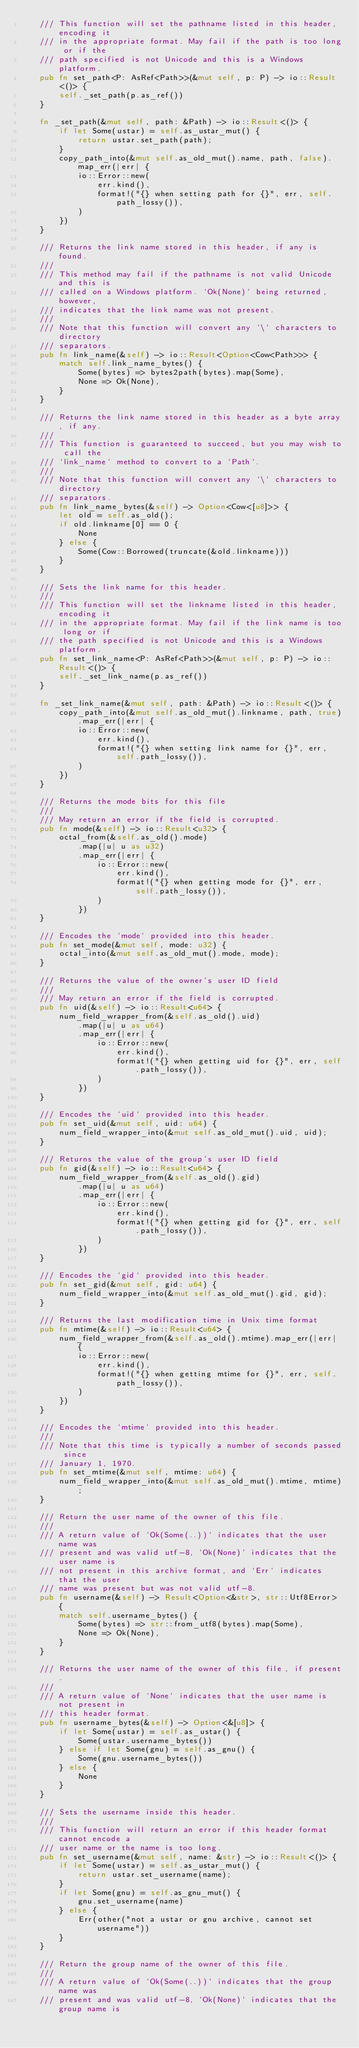<code> <loc_0><loc_0><loc_500><loc_500><_Rust_>    /// This function will set the pathname listed in this header, encoding it
    /// in the appropriate format. May fail if the path is too long or if the
    /// path specified is not Unicode and this is a Windows platform.
    pub fn set_path<P: AsRef<Path>>(&mut self, p: P) -> io::Result<()> {
        self._set_path(p.as_ref())
    }

    fn _set_path(&mut self, path: &Path) -> io::Result<()> {
        if let Some(ustar) = self.as_ustar_mut() {
            return ustar.set_path(path);
        }
        copy_path_into(&mut self.as_old_mut().name, path, false).map_err(|err| {
            io::Error::new(
                err.kind(),
                format!("{} when setting path for {}", err, self.path_lossy()),
            )
        })
    }

    /// Returns the link name stored in this header, if any is found.
    ///
    /// This method may fail if the pathname is not valid Unicode and this is
    /// called on a Windows platform. `Ok(None)` being returned, however,
    /// indicates that the link name was not present.
    ///
    /// Note that this function will convert any `\` characters to directory
    /// separators.
    pub fn link_name(&self) -> io::Result<Option<Cow<Path>>> {
        match self.link_name_bytes() {
            Some(bytes) => bytes2path(bytes).map(Some),
            None => Ok(None),
        }
    }

    /// Returns the link name stored in this header as a byte array, if any.
    ///
    /// This function is guaranteed to succeed, but you may wish to call the
    /// `link_name` method to convert to a `Path`.
    ///
    /// Note that this function will convert any `\` characters to directory
    /// separators.
    pub fn link_name_bytes(&self) -> Option<Cow<[u8]>> {
        let old = self.as_old();
        if old.linkname[0] == 0 {
            None
        } else {
            Some(Cow::Borrowed(truncate(&old.linkname)))
        }
    }

    /// Sets the link name for this header.
    ///
    /// This function will set the linkname listed in this header, encoding it
    /// in the appropriate format. May fail if the link name is too long or if
    /// the path specified is not Unicode and this is a Windows platform.
    pub fn set_link_name<P: AsRef<Path>>(&mut self, p: P) -> io::Result<()> {
        self._set_link_name(p.as_ref())
    }

    fn _set_link_name(&mut self, path: &Path) -> io::Result<()> {
        copy_path_into(&mut self.as_old_mut().linkname, path, true).map_err(|err| {
            io::Error::new(
                err.kind(),
                format!("{} when setting link name for {}", err, self.path_lossy()),
            )
        })
    }

    /// Returns the mode bits for this file
    ///
    /// May return an error if the field is corrupted.
    pub fn mode(&self) -> io::Result<u32> {
        octal_from(&self.as_old().mode)
            .map(|u| u as u32)
            .map_err(|err| {
                io::Error::new(
                    err.kind(),
                    format!("{} when getting mode for {}", err, self.path_lossy()),
                )
            })
    }

    /// Encodes the `mode` provided into this header.
    pub fn set_mode(&mut self, mode: u32) {
        octal_into(&mut self.as_old_mut().mode, mode);
    }

    /// Returns the value of the owner's user ID field
    ///
    /// May return an error if the field is corrupted.
    pub fn uid(&self) -> io::Result<u64> {
        num_field_wrapper_from(&self.as_old().uid)
            .map(|u| u as u64)
            .map_err(|err| {
                io::Error::new(
                    err.kind(),
                    format!("{} when getting uid for {}", err, self.path_lossy()),
                )
            })
    }

    /// Encodes the `uid` provided into this header.
    pub fn set_uid(&mut self, uid: u64) {
        num_field_wrapper_into(&mut self.as_old_mut().uid, uid);
    }

    /// Returns the value of the group's user ID field
    pub fn gid(&self) -> io::Result<u64> {
        num_field_wrapper_from(&self.as_old().gid)
            .map(|u| u as u64)
            .map_err(|err| {
                io::Error::new(
                    err.kind(),
                    format!("{} when getting gid for {}", err, self.path_lossy()),
                )
            })
    }

    /// Encodes the `gid` provided into this header.
    pub fn set_gid(&mut self, gid: u64) {
        num_field_wrapper_into(&mut self.as_old_mut().gid, gid);
    }

    /// Returns the last modification time in Unix time format
    pub fn mtime(&self) -> io::Result<u64> {
        num_field_wrapper_from(&self.as_old().mtime).map_err(|err| {
            io::Error::new(
                err.kind(),
                format!("{} when getting mtime for {}", err, self.path_lossy()),
            )
        })
    }

    /// Encodes the `mtime` provided into this header.
    ///
    /// Note that this time is typically a number of seconds passed since
    /// January 1, 1970.
    pub fn set_mtime(&mut self, mtime: u64) {
        num_field_wrapper_into(&mut self.as_old_mut().mtime, mtime);
    }

    /// Return the user name of the owner of this file.
    ///
    /// A return value of `Ok(Some(..))` indicates that the user name was
    /// present and was valid utf-8, `Ok(None)` indicates that the user name is
    /// not present in this archive format, and `Err` indicates that the user
    /// name was present but was not valid utf-8.
    pub fn username(&self) -> Result<Option<&str>, str::Utf8Error> {
        match self.username_bytes() {
            Some(bytes) => str::from_utf8(bytes).map(Some),
            None => Ok(None),
        }
    }

    /// Returns the user name of the owner of this file, if present.
    ///
    /// A return value of `None` indicates that the user name is not present in
    /// this header format.
    pub fn username_bytes(&self) -> Option<&[u8]> {
        if let Some(ustar) = self.as_ustar() {
            Some(ustar.username_bytes())
        } else if let Some(gnu) = self.as_gnu() {
            Some(gnu.username_bytes())
        } else {
            None
        }
    }

    /// Sets the username inside this header.
    ///
    /// This function will return an error if this header format cannot encode a
    /// user name or the name is too long.
    pub fn set_username(&mut self, name: &str) -> io::Result<()> {
        if let Some(ustar) = self.as_ustar_mut() {
            return ustar.set_username(name);
        }
        if let Some(gnu) = self.as_gnu_mut() {
            gnu.set_username(name)
        } else {
            Err(other("not a ustar or gnu archive, cannot set username"))
        }
    }

    /// Return the group name of the owner of this file.
    ///
    /// A return value of `Ok(Some(..))` indicates that the group name was
    /// present and was valid utf-8, `Ok(None)` indicates that the group name is</code> 